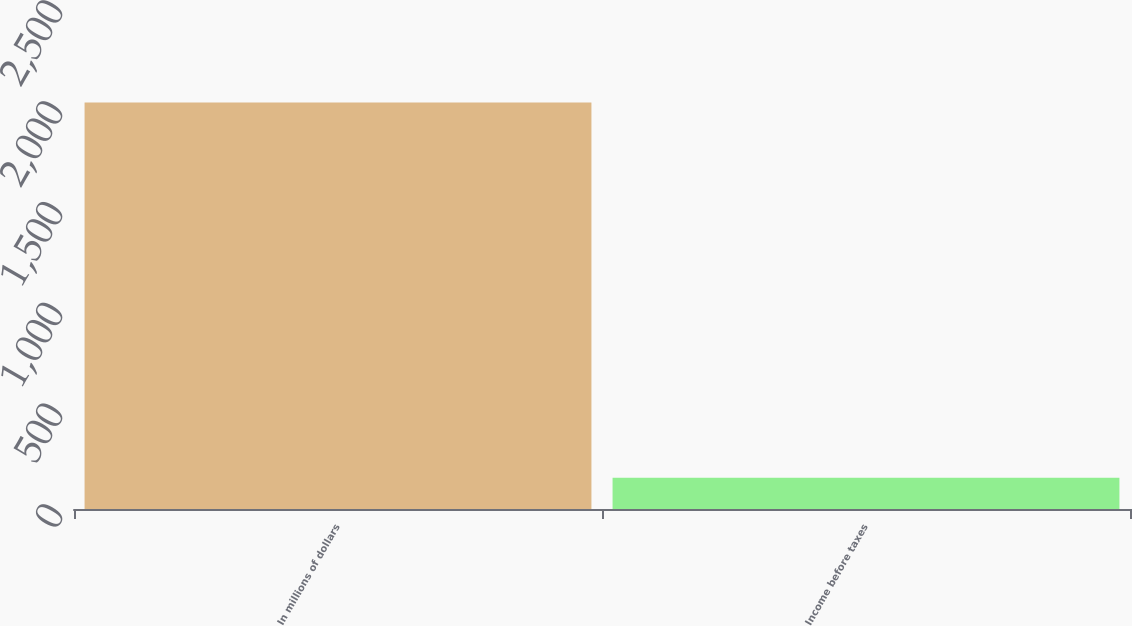<chart> <loc_0><loc_0><loc_500><loc_500><bar_chart><fcel>In millions of dollars<fcel>Income before taxes<nl><fcel>2016<fcel>155<nl></chart> 